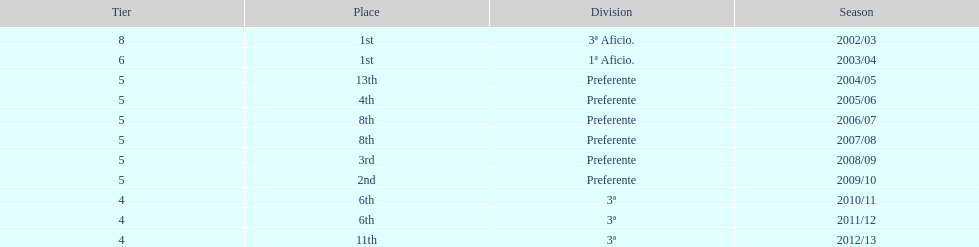How many times did internacional de madrid cf end the season at the top of their division? 2. 